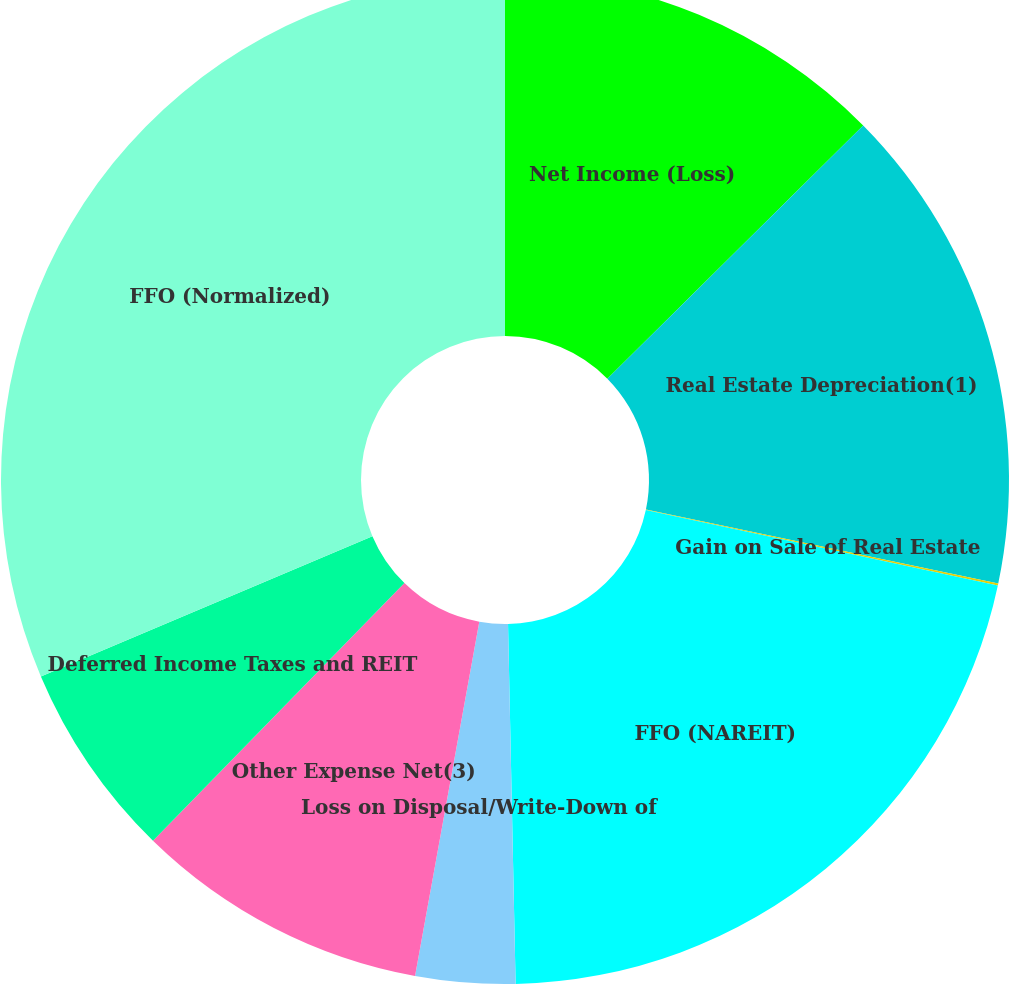Convert chart. <chart><loc_0><loc_0><loc_500><loc_500><pie_chart><fcel>Net Income (Loss)<fcel>Real Estate Depreciation(1)<fcel>Gain on Sale of Real Estate<fcel>FFO (NAREIT)<fcel>Loss on Disposal/Write-Down of<fcel>Other Expense Net(3)<fcel>Deferred Income Taxes and REIT<fcel>FFO (Normalized)<nl><fcel>12.58%<fcel>15.71%<fcel>0.06%<fcel>21.31%<fcel>3.19%<fcel>9.45%<fcel>6.32%<fcel>31.37%<nl></chart> 